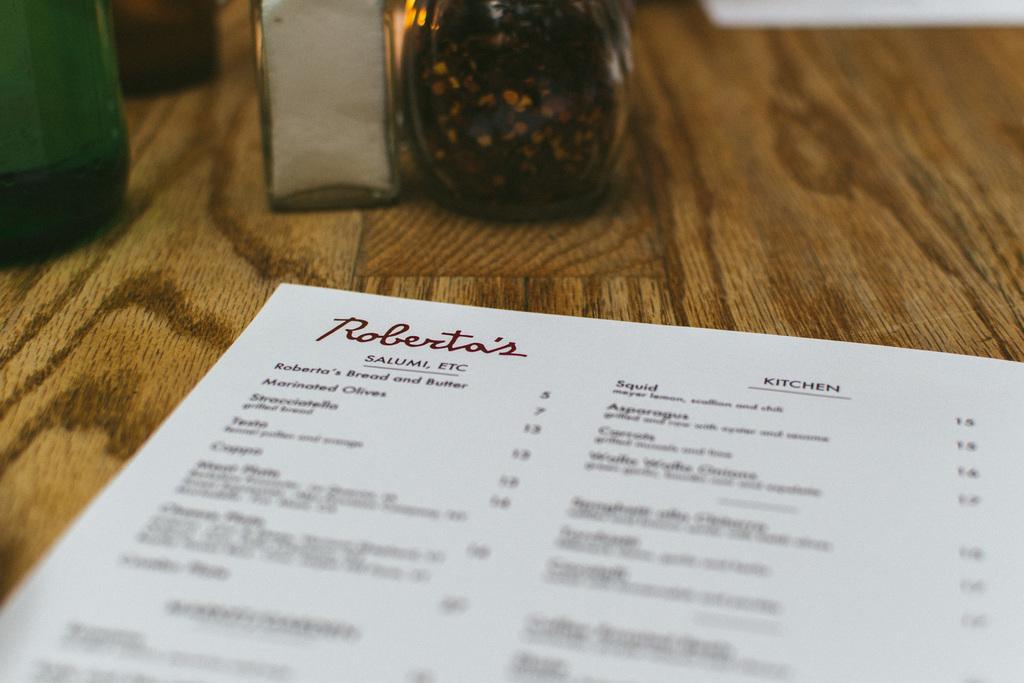How would you summarize this image in a sentence or two? In this image I can see a brown colored surface and on the surface I can see two pieces of papers and few bottles which are green, white and brown in color. 